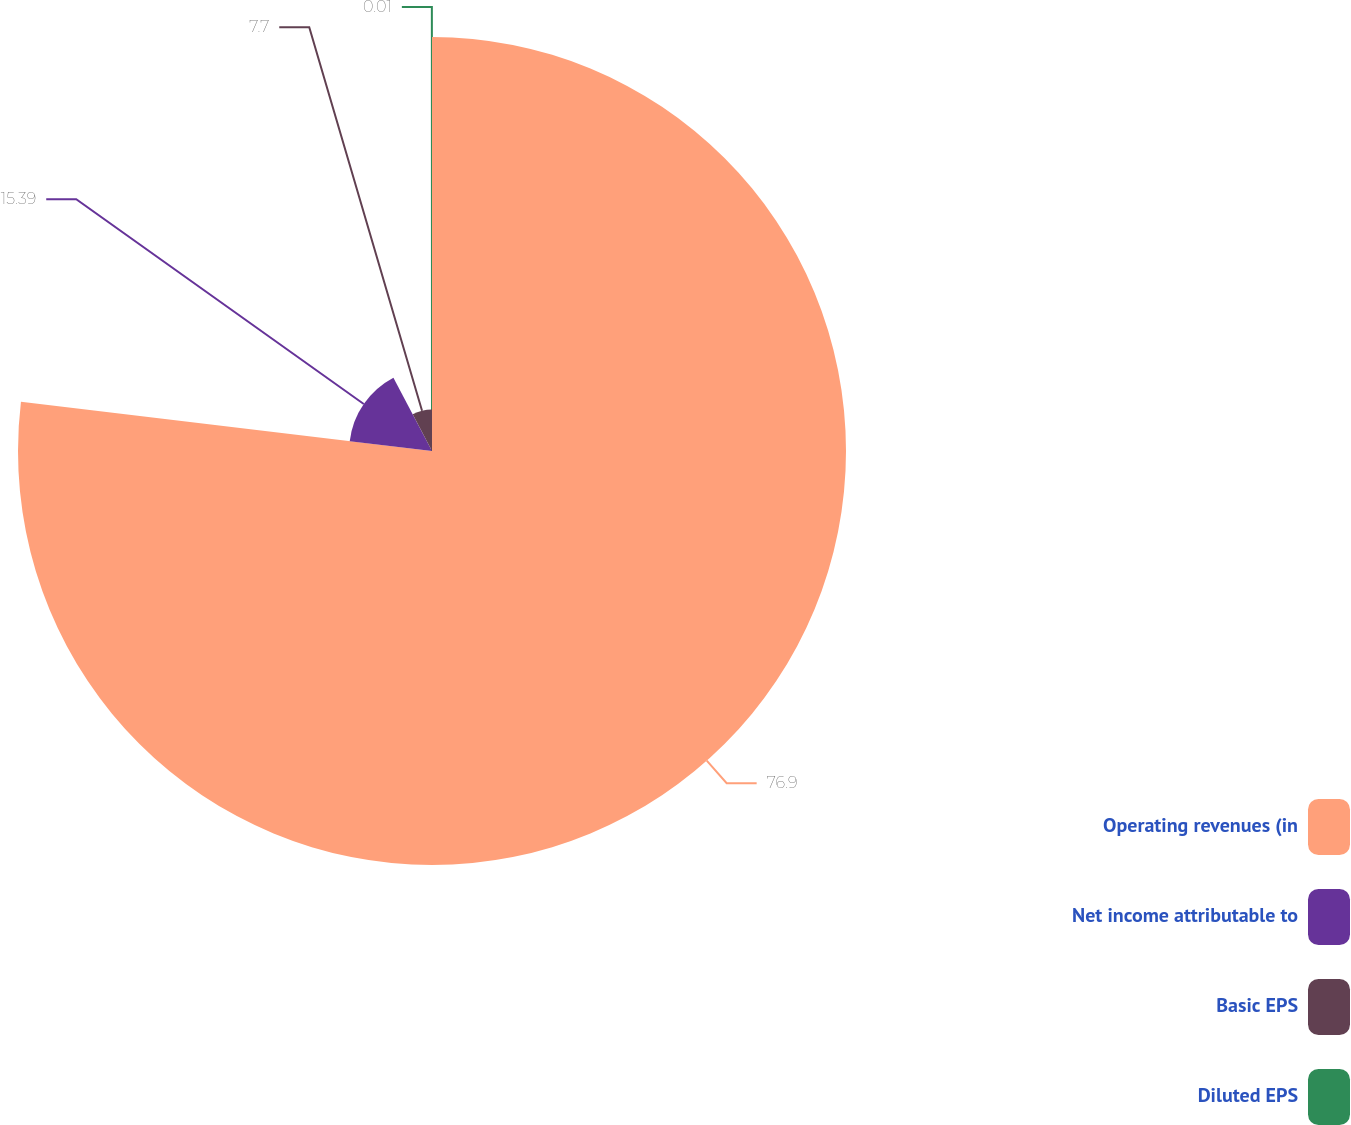Convert chart. <chart><loc_0><loc_0><loc_500><loc_500><pie_chart><fcel>Operating revenues (in<fcel>Net income attributable to<fcel>Basic EPS<fcel>Diluted EPS<nl><fcel>76.9%<fcel>15.39%<fcel>7.7%<fcel>0.01%<nl></chart> 